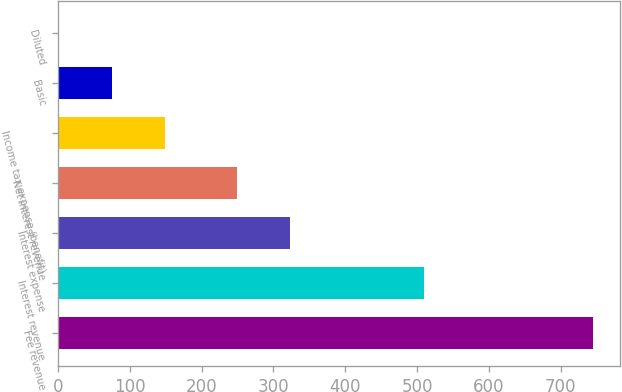<chart> <loc_0><loc_0><loc_500><loc_500><bar_chart><fcel>Fee revenue<fcel>Interest revenue<fcel>Interest expense<fcel>Net interest revenue<fcel>Income tax expense (benefit)<fcel>Basic<fcel>Diluted<nl><fcel>745<fcel>510<fcel>323.45<fcel>249<fcel>149.44<fcel>74.99<fcel>0.54<nl></chart> 